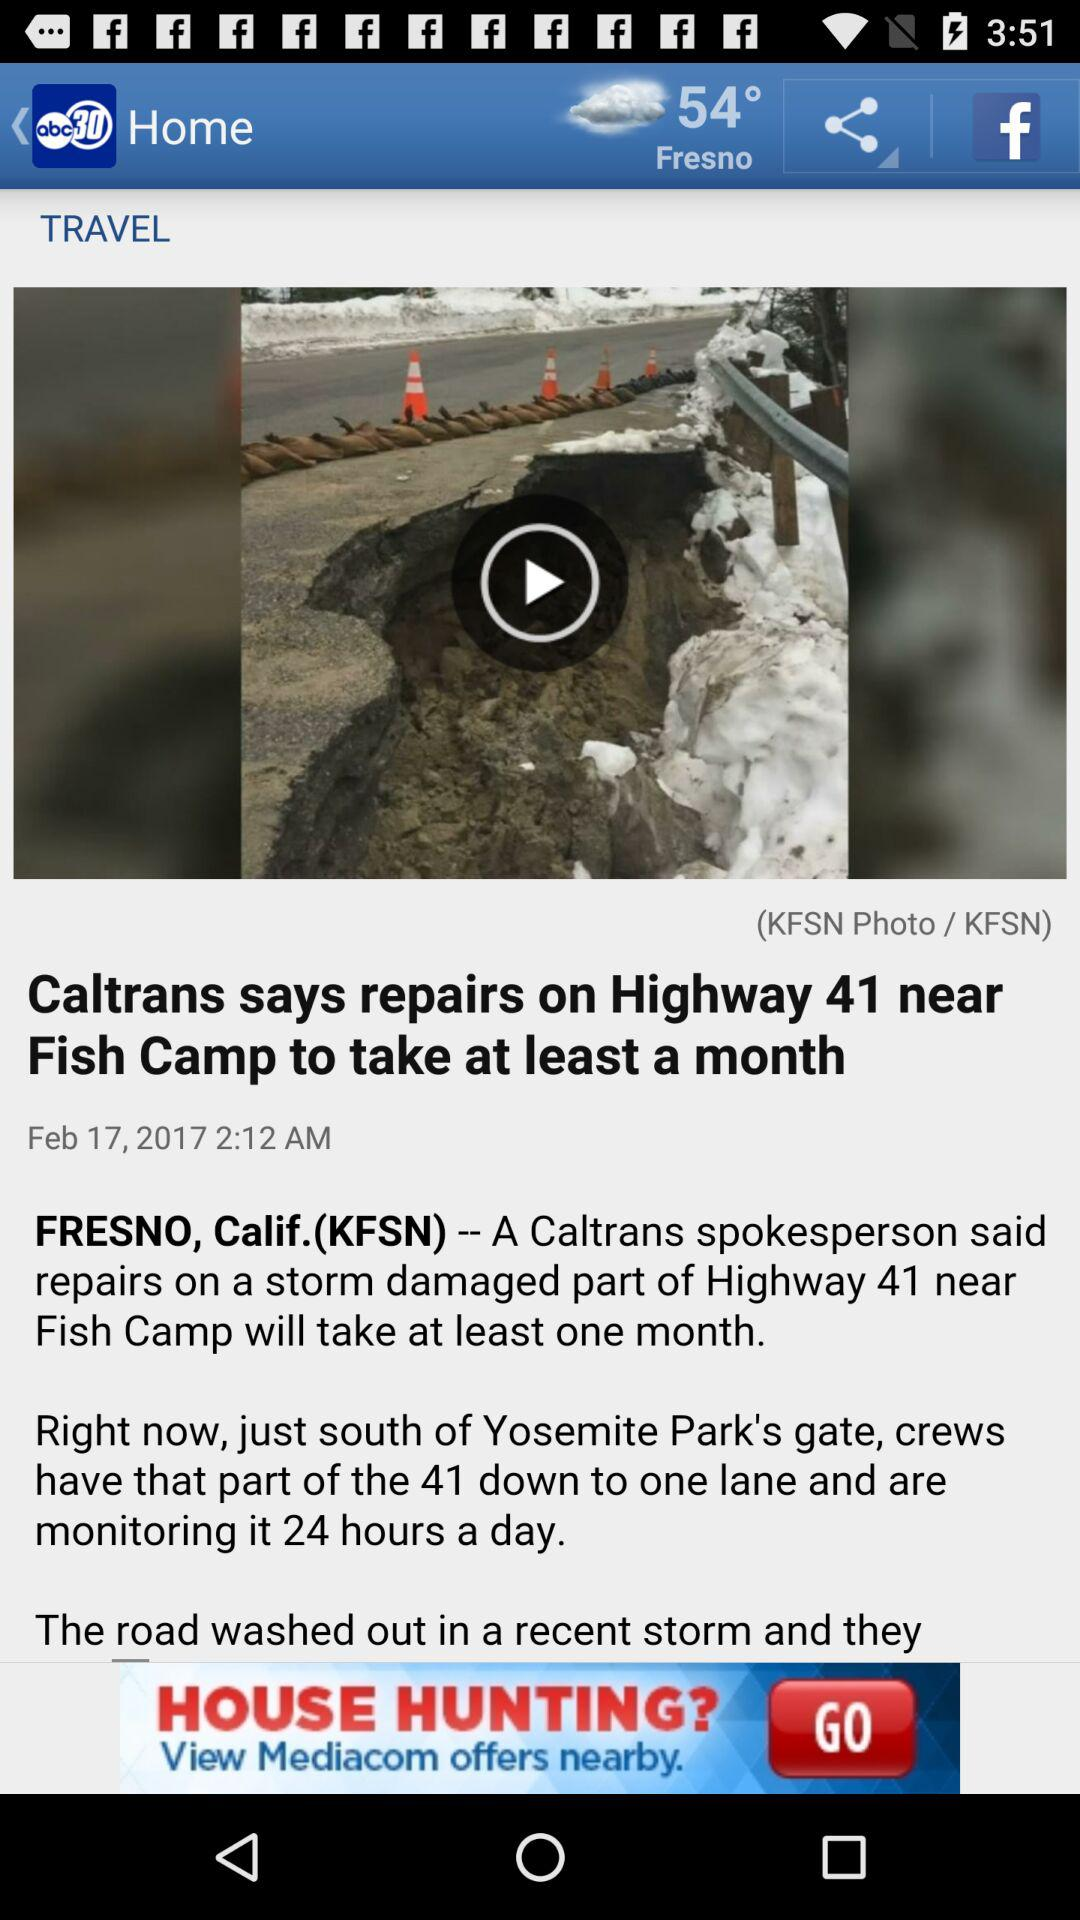What is the mentioned date? The mentioned date is February 17, 2017. 